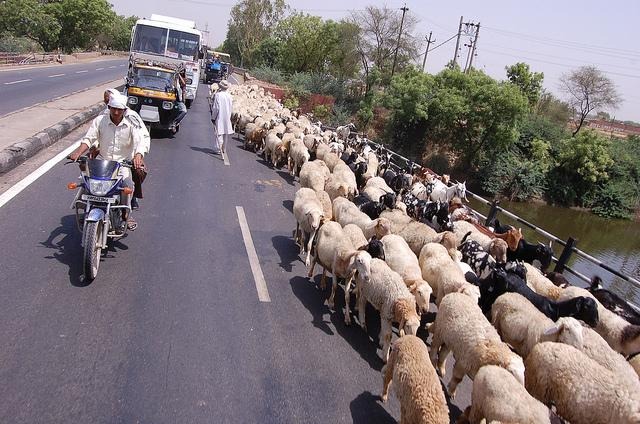What is clogging up the street? sheep 